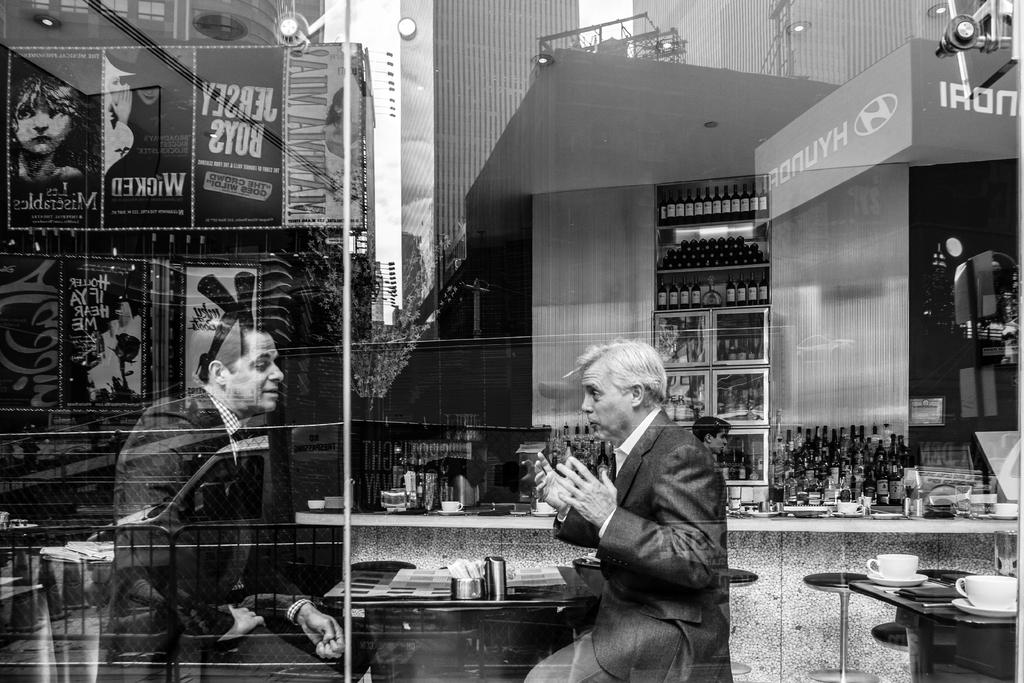What type of structure is present in the image? There is a wall in the image. What is attached to the wall? There are shelves in the image. What objects can be seen on the shelves? There are bottles in the image. What additional decoration or information is present in the image? There is a banner in the image. How many people are visible in the image? There are two people in the image. What type of sign can be seen on the side of the head of one of the people in the image? There is no sign present on the side of the head of any person in the image. 